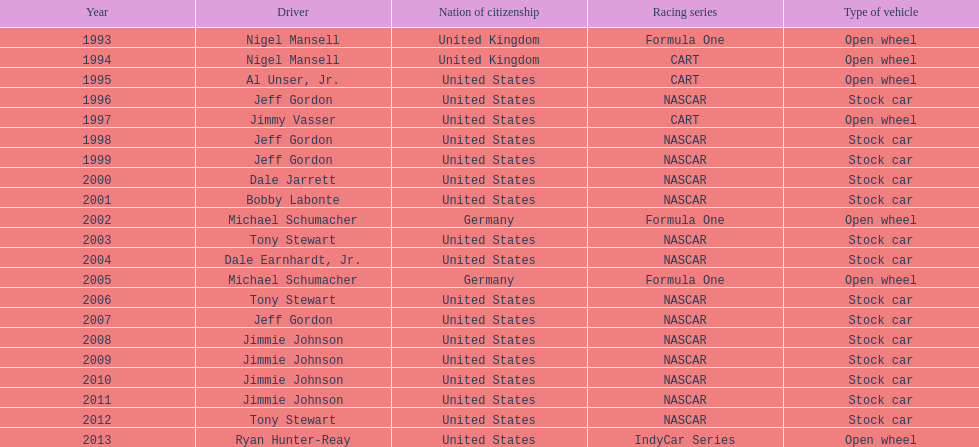Apart from nascar, which other racing series have produced espy-winning drivers? Formula One, CART, IndyCar Series. 